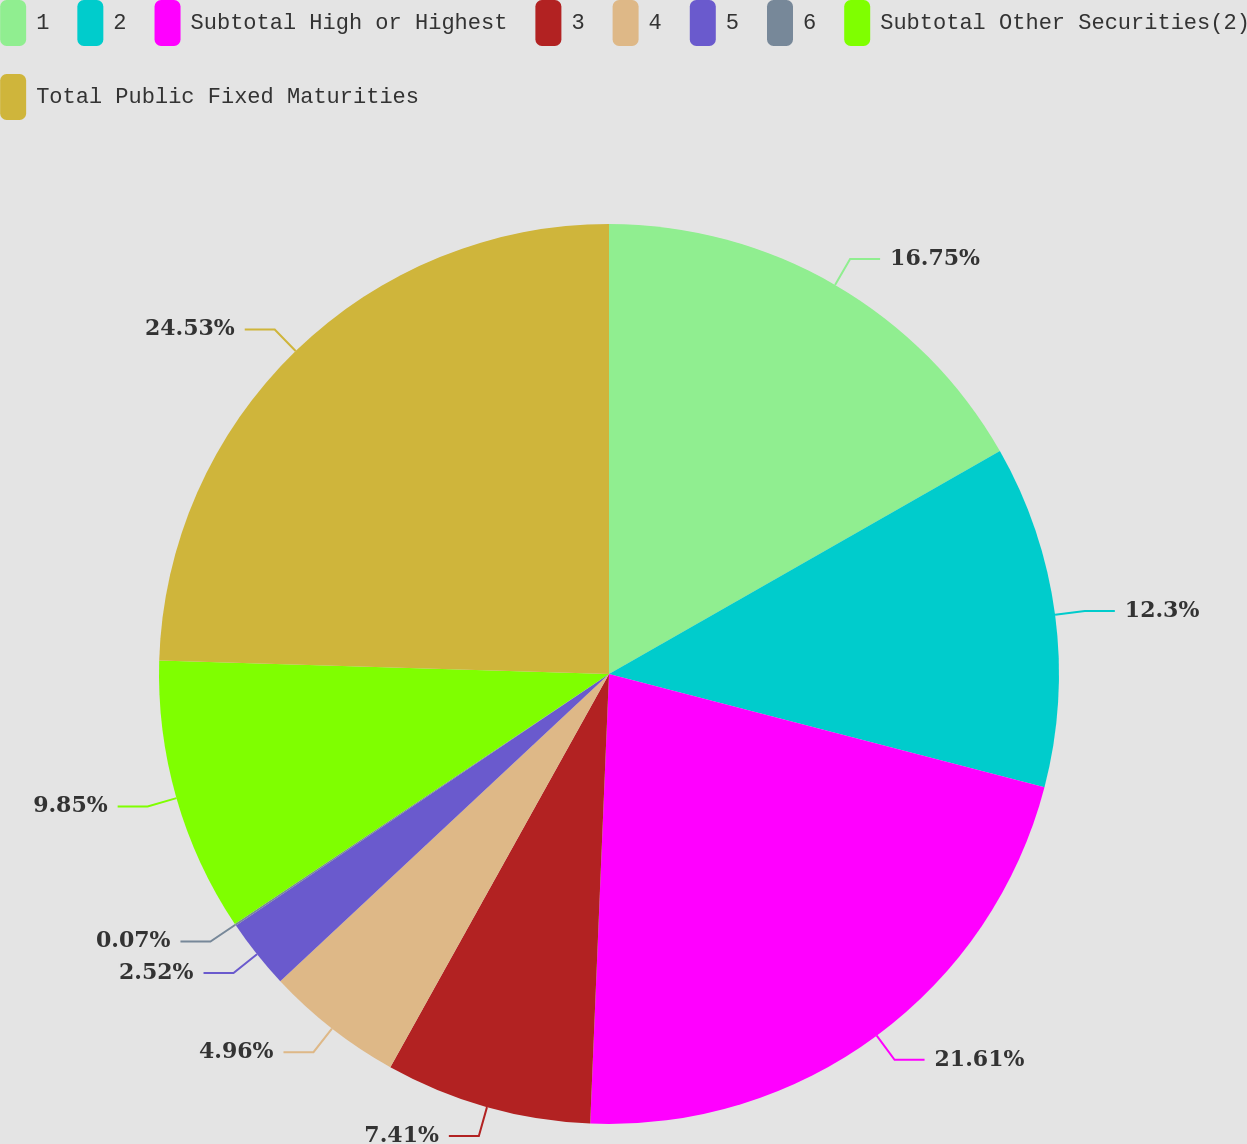Convert chart to OTSL. <chart><loc_0><loc_0><loc_500><loc_500><pie_chart><fcel>1<fcel>2<fcel>Subtotal High or Highest<fcel>3<fcel>4<fcel>5<fcel>6<fcel>Subtotal Other Securities(2)<fcel>Total Public Fixed Maturities<nl><fcel>16.75%<fcel>12.3%<fcel>21.61%<fcel>7.41%<fcel>4.96%<fcel>2.52%<fcel>0.07%<fcel>9.85%<fcel>24.52%<nl></chart> 